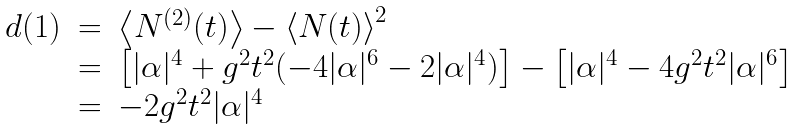<formula> <loc_0><loc_0><loc_500><loc_500>\begin{array} { l c l } d ( 1 ) & = & \left \langle N ^ { ( 2 ) } ( t ) \right \rangle - \left \langle N ( t ) \right \rangle ^ { 2 } \\ & = & \left [ | \alpha | ^ { 4 } + g ^ { 2 } t ^ { 2 } ( - 4 | \alpha | ^ { 6 } - 2 | \alpha | ^ { 4 } ) \right ] - \left [ | \alpha | ^ { 4 } - 4 g ^ { 2 } t ^ { 2 } | \alpha | ^ { 6 } \right ] \\ & = & - 2 g ^ { 2 } t ^ { 2 } | \alpha | ^ { 4 } \end{array}</formula> 